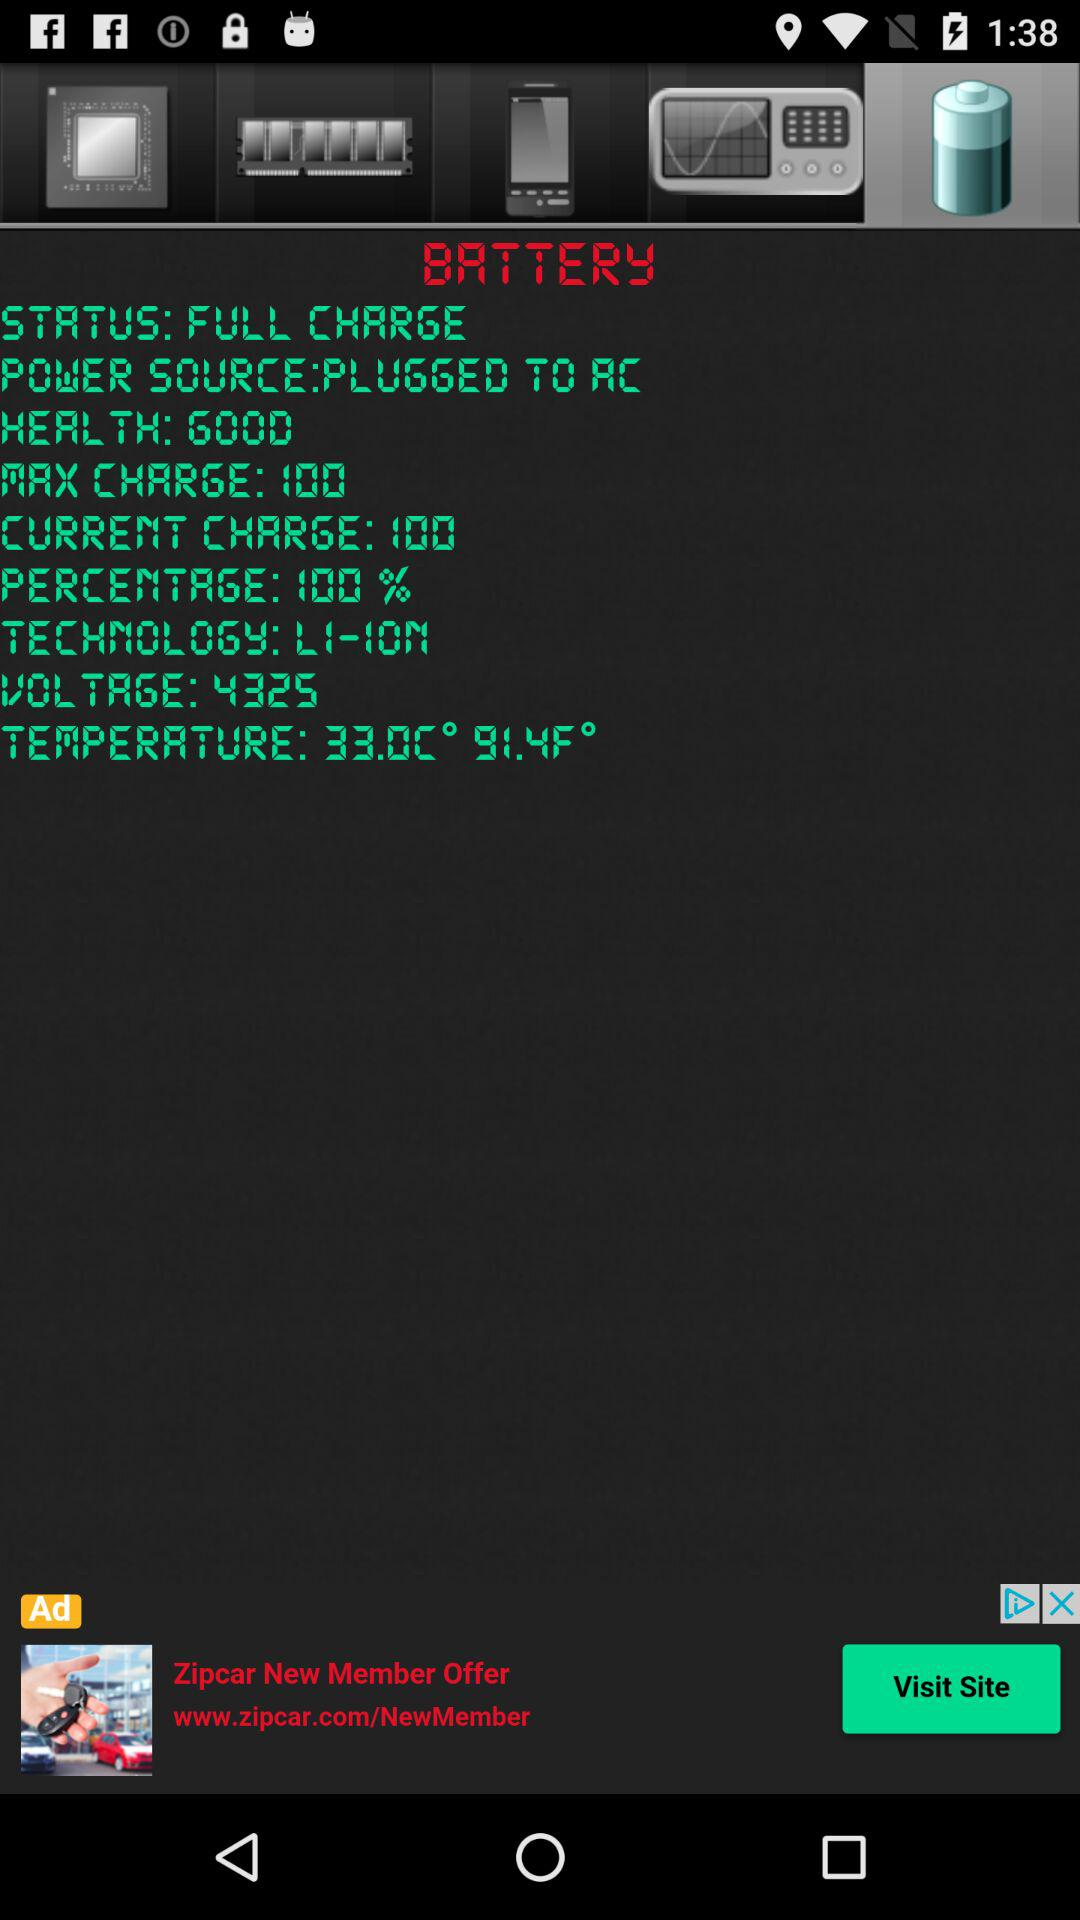What is the power source? The power source is AC. 